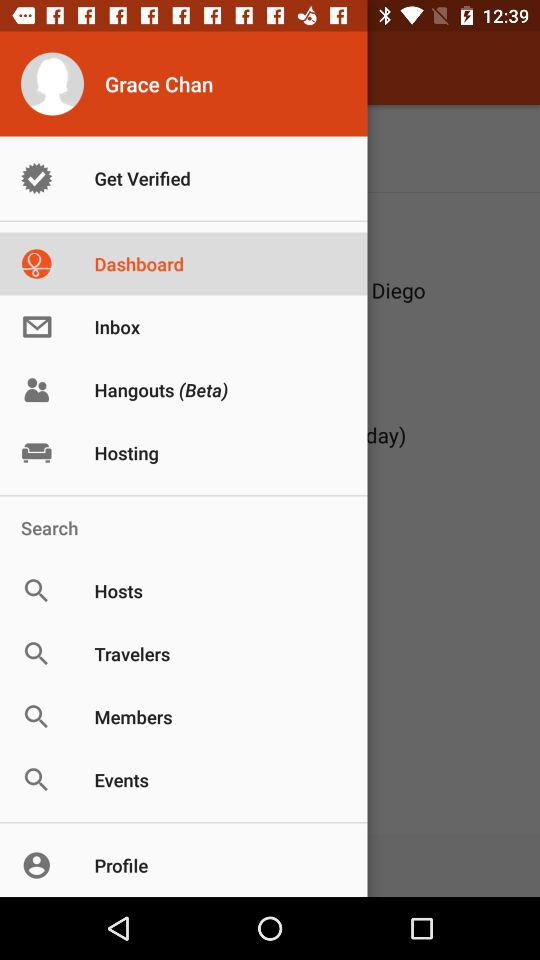What is the status of the get verified?
When the provided information is insufficient, respond with <no answer>. <no answer> 